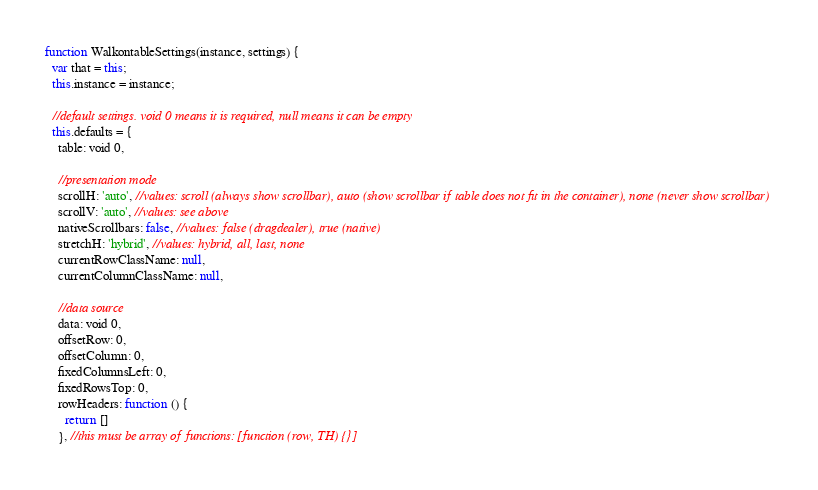<code> <loc_0><loc_0><loc_500><loc_500><_JavaScript_>function WalkontableSettings(instance, settings) {
  var that = this;
  this.instance = instance;

  //default settings. void 0 means it is required, null means it can be empty
  this.defaults = {
    table: void 0,

    //presentation mode
    scrollH: 'auto', //values: scroll (always show scrollbar), auto (show scrollbar if table does not fit in the container), none (never show scrollbar)
    scrollV: 'auto', //values: see above
    nativeScrollbars: false, //values: false (dragdealer), true (native)
    stretchH: 'hybrid', //values: hybrid, all, last, none
    currentRowClassName: null,
    currentColumnClassName: null,

    //data source
    data: void 0,
    offsetRow: 0,
    offsetColumn: 0,
    fixedColumnsLeft: 0,
    fixedRowsTop: 0,
    rowHeaders: function () {
      return []
    }, //this must be array of functions: [function (row, TH) {}]</code> 